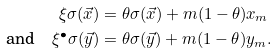<formula> <loc_0><loc_0><loc_500><loc_500>\xi \sigma ( \vec { x } ) & = \theta \sigma ( \vec { x } ) + m ( 1 - \theta ) x _ { m } \\ \text {and} \quad \xi ^ { \bullet } \sigma ( \vec { y } ) & = \theta \sigma ( \vec { y } ) + m ( 1 - \theta ) y _ { m } .</formula> 